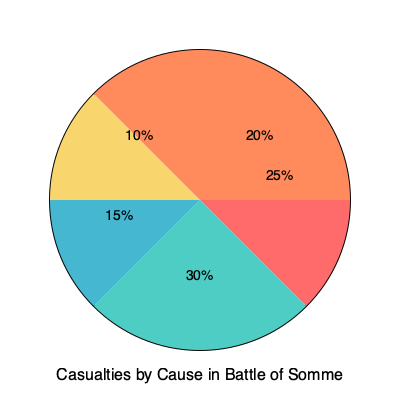Based on the pie chart showing casualties by cause in the Battle of Somme, what percentage of casualties were caused by factors other than artillery fire and small arms fire combined? To solve this problem, we need to follow these steps:

1. Identify the percentages for artillery fire and small arms fire:
   - Artillery fire: 30%
   - Small arms fire: 25%

2. Calculate the combined percentage of these two causes:
   $30\% + 25\% = 55\%$

3. The total of all causes must equal 100%. So, to find the percentage of casualties caused by other factors, we subtract the combined percentage from 100%:

   $100\% - 55\% = 45\%$

This 45% represents the sum of the remaining three sections in the pie chart:
- Disease and exposure: 20%
- Gas attacks: 10%
- Other causes: 15%

Indeed, $20\% + 10\% + 15\% = 45\%$, which confirms our calculation.
Answer: 45% 